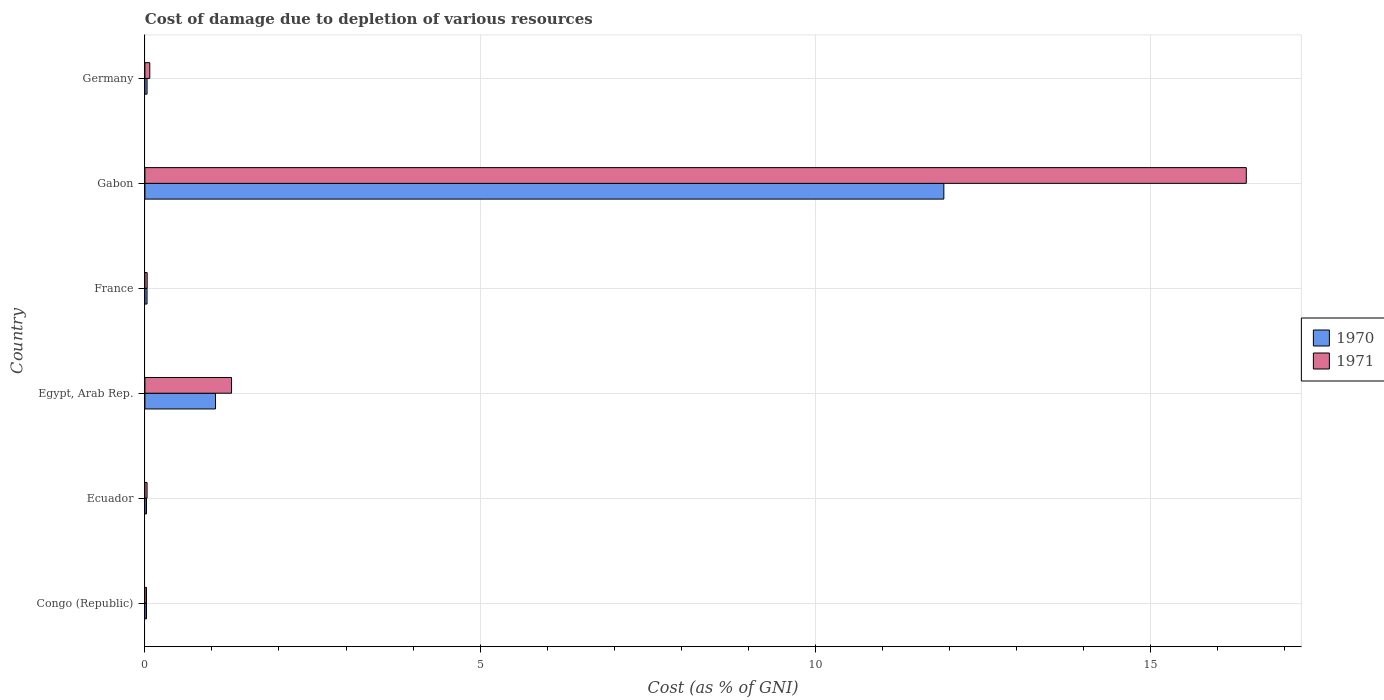How many different coloured bars are there?
Offer a terse response. 2. How many groups of bars are there?
Your response must be concise. 6. Are the number of bars per tick equal to the number of legend labels?
Your answer should be very brief. Yes. How many bars are there on the 6th tick from the top?
Offer a terse response. 2. How many bars are there on the 2nd tick from the bottom?
Your answer should be compact. 2. In how many cases, is the number of bars for a given country not equal to the number of legend labels?
Your response must be concise. 0. What is the cost of damage caused due to the depletion of various resources in 1970 in Congo (Republic)?
Offer a very short reply. 0.02. Across all countries, what is the maximum cost of damage caused due to the depletion of various resources in 1970?
Offer a very short reply. 11.92. Across all countries, what is the minimum cost of damage caused due to the depletion of various resources in 1970?
Provide a succinct answer. 0.02. In which country was the cost of damage caused due to the depletion of various resources in 1970 maximum?
Give a very brief answer. Gabon. In which country was the cost of damage caused due to the depletion of various resources in 1971 minimum?
Make the answer very short. Congo (Republic). What is the total cost of damage caused due to the depletion of various resources in 1970 in the graph?
Your answer should be compact. 13.08. What is the difference between the cost of damage caused due to the depletion of various resources in 1971 in Congo (Republic) and that in Ecuador?
Ensure brevity in your answer.  -0.01. What is the difference between the cost of damage caused due to the depletion of various resources in 1971 in Egypt, Arab Rep. and the cost of damage caused due to the depletion of various resources in 1970 in France?
Offer a very short reply. 1.26. What is the average cost of damage caused due to the depletion of various resources in 1970 per country?
Your response must be concise. 2.18. What is the difference between the cost of damage caused due to the depletion of various resources in 1970 and cost of damage caused due to the depletion of various resources in 1971 in Gabon?
Your answer should be very brief. -4.51. In how many countries, is the cost of damage caused due to the depletion of various resources in 1971 greater than 13 %?
Your answer should be very brief. 1. What is the ratio of the cost of damage caused due to the depletion of various resources in 1971 in Congo (Republic) to that in Germany?
Offer a terse response. 0.32. Is the cost of damage caused due to the depletion of various resources in 1971 in Ecuador less than that in Gabon?
Offer a very short reply. Yes. What is the difference between the highest and the second highest cost of damage caused due to the depletion of various resources in 1971?
Your response must be concise. 15.14. What is the difference between the highest and the lowest cost of damage caused due to the depletion of various resources in 1970?
Give a very brief answer. 11.9. What does the 1st bar from the bottom in France represents?
Provide a succinct answer. 1970. How many bars are there?
Provide a short and direct response. 12. Are the values on the major ticks of X-axis written in scientific E-notation?
Offer a terse response. No. How many legend labels are there?
Your response must be concise. 2. How are the legend labels stacked?
Provide a succinct answer. Vertical. What is the title of the graph?
Offer a terse response. Cost of damage due to depletion of various resources. Does "1963" appear as one of the legend labels in the graph?
Provide a succinct answer. No. What is the label or title of the X-axis?
Provide a succinct answer. Cost (as % of GNI). What is the label or title of the Y-axis?
Provide a short and direct response. Country. What is the Cost (as % of GNI) of 1970 in Congo (Republic)?
Your answer should be very brief. 0.02. What is the Cost (as % of GNI) of 1971 in Congo (Republic)?
Provide a succinct answer. 0.02. What is the Cost (as % of GNI) in 1970 in Ecuador?
Offer a terse response. 0.02. What is the Cost (as % of GNI) of 1971 in Ecuador?
Your answer should be compact. 0.03. What is the Cost (as % of GNI) of 1970 in Egypt, Arab Rep.?
Your answer should be very brief. 1.05. What is the Cost (as % of GNI) of 1971 in Egypt, Arab Rep.?
Offer a very short reply. 1.29. What is the Cost (as % of GNI) of 1970 in France?
Ensure brevity in your answer.  0.03. What is the Cost (as % of GNI) of 1971 in France?
Your answer should be very brief. 0.03. What is the Cost (as % of GNI) in 1970 in Gabon?
Your answer should be compact. 11.92. What is the Cost (as % of GNI) in 1971 in Gabon?
Make the answer very short. 16.43. What is the Cost (as % of GNI) in 1970 in Germany?
Ensure brevity in your answer.  0.03. What is the Cost (as % of GNI) of 1971 in Germany?
Make the answer very short. 0.07. Across all countries, what is the maximum Cost (as % of GNI) of 1970?
Ensure brevity in your answer.  11.92. Across all countries, what is the maximum Cost (as % of GNI) in 1971?
Your answer should be compact. 16.43. Across all countries, what is the minimum Cost (as % of GNI) of 1970?
Offer a very short reply. 0.02. Across all countries, what is the minimum Cost (as % of GNI) in 1971?
Give a very brief answer. 0.02. What is the total Cost (as % of GNI) in 1970 in the graph?
Keep it short and to the point. 13.08. What is the total Cost (as % of GNI) in 1971 in the graph?
Ensure brevity in your answer.  17.89. What is the difference between the Cost (as % of GNI) in 1971 in Congo (Republic) and that in Ecuador?
Your response must be concise. -0.01. What is the difference between the Cost (as % of GNI) of 1970 in Congo (Republic) and that in Egypt, Arab Rep.?
Provide a short and direct response. -1.03. What is the difference between the Cost (as % of GNI) in 1971 in Congo (Republic) and that in Egypt, Arab Rep.?
Your answer should be very brief. -1.27. What is the difference between the Cost (as % of GNI) in 1970 in Congo (Republic) and that in France?
Offer a very short reply. -0.01. What is the difference between the Cost (as % of GNI) in 1971 in Congo (Republic) and that in France?
Your answer should be compact. -0.01. What is the difference between the Cost (as % of GNI) of 1970 in Congo (Republic) and that in Gabon?
Provide a succinct answer. -11.9. What is the difference between the Cost (as % of GNI) in 1971 in Congo (Republic) and that in Gabon?
Your response must be concise. -16.41. What is the difference between the Cost (as % of GNI) in 1970 in Congo (Republic) and that in Germany?
Your answer should be compact. -0.01. What is the difference between the Cost (as % of GNI) in 1971 in Congo (Republic) and that in Germany?
Make the answer very short. -0.05. What is the difference between the Cost (as % of GNI) in 1970 in Ecuador and that in Egypt, Arab Rep.?
Your response must be concise. -1.03. What is the difference between the Cost (as % of GNI) in 1971 in Ecuador and that in Egypt, Arab Rep.?
Keep it short and to the point. -1.26. What is the difference between the Cost (as % of GNI) in 1970 in Ecuador and that in France?
Give a very brief answer. -0.01. What is the difference between the Cost (as % of GNI) in 1971 in Ecuador and that in France?
Your answer should be very brief. -0. What is the difference between the Cost (as % of GNI) in 1970 in Ecuador and that in Gabon?
Give a very brief answer. -11.9. What is the difference between the Cost (as % of GNI) in 1971 in Ecuador and that in Gabon?
Keep it short and to the point. -16.4. What is the difference between the Cost (as % of GNI) of 1970 in Ecuador and that in Germany?
Your answer should be compact. -0.01. What is the difference between the Cost (as % of GNI) in 1971 in Ecuador and that in Germany?
Ensure brevity in your answer.  -0.04. What is the difference between the Cost (as % of GNI) in 1970 in Egypt, Arab Rep. and that in France?
Offer a very short reply. 1.02. What is the difference between the Cost (as % of GNI) in 1971 in Egypt, Arab Rep. and that in France?
Your answer should be very brief. 1.26. What is the difference between the Cost (as % of GNI) in 1970 in Egypt, Arab Rep. and that in Gabon?
Offer a terse response. -10.87. What is the difference between the Cost (as % of GNI) of 1971 in Egypt, Arab Rep. and that in Gabon?
Make the answer very short. -15.14. What is the difference between the Cost (as % of GNI) of 1970 in Egypt, Arab Rep. and that in Germany?
Keep it short and to the point. 1.02. What is the difference between the Cost (as % of GNI) in 1971 in Egypt, Arab Rep. and that in Germany?
Offer a very short reply. 1.22. What is the difference between the Cost (as % of GNI) of 1970 in France and that in Gabon?
Give a very brief answer. -11.89. What is the difference between the Cost (as % of GNI) in 1971 in France and that in Gabon?
Make the answer very short. -16.4. What is the difference between the Cost (as % of GNI) of 1970 in France and that in Germany?
Offer a very short reply. -0. What is the difference between the Cost (as % of GNI) of 1971 in France and that in Germany?
Offer a very short reply. -0.04. What is the difference between the Cost (as % of GNI) in 1970 in Gabon and that in Germany?
Give a very brief answer. 11.89. What is the difference between the Cost (as % of GNI) in 1971 in Gabon and that in Germany?
Your response must be concise. 16.36. What is the difference between the Cost (as % of GNI) in 1970 in Congo (Republic) and the Cost (as % of GNI) in 1971 in Ecuador?
Your response must be concise. -0.01. What is the difference between the Cost (as % of GNI) of 1970 in Congo (Republic) and the Cost (as % of GNI) of 1971 in Egypt, Arab Rep.?
Offer a very short reply. -1.27. What is the difference between the Cost (as % of GNI) in 1970 in Congo (Republic) and the Cost (as % of GNI) in 1971 in France?
Offer a terse response. -0.01. What is the difference between the Cost (as % of GNI) of 1970 in Congo (Republic) and the Cost (as % of GNI) of 1971 in Gabon?
Keep it short and to the point. -16.41. What is the difference between the Cost (as % of GNI) of 1970 in Congo (Republic) and the Cost (as % of GNI) of 1971 in Germany?
Your answer should be very brief. -0.05. What is the difference between the Cost (as % of GNI) in 1970 in Ecuador and the Cost (as % of GNI) in 1971 in Egypt, Arab Rep.?
Keep it short and to the point. -1.27. What is the difference between the Cost (as % of GNI) of 1970 in Ecuador and the Cost (as % of GNI) of 1971 in France?
Ensure brevity in your answer.  -0.01. What is the difference between the Cost (as % of GNI) of 1970 in Ecuador and the Cost (as % of GNI) of 1971 in Gabon?
Offer a terse response. -16.41. What is the difference between the Cost (as % of GNI) in 1970 in Ecuador and the Cost (as % of GNI) in 1971 in Germany?
Give a very brief answer. -0.05. What is the difference between the Cost (as % of GNI) of 1970 in Egypt, Arab Rep. and the Cost (as % of GNI) of 1971 in Gabon?
Your response must be concise. -15.38. What is the difference between the Cost (as % of GNI) of 1970 in Egypt, Arab Rep. and the Cost (as % of GNI) of 1971 in Germany?
Provide a succinct answer. 0.98. What is the difference between the Cost (as % of GNI) in 1970 in France and the Cost (as % of GNI) in 1971 in Gabon?
Keep it short and to the point. -16.4. What is the difference between the Cost (as % of GNI) in 1970 in France and the Cost (as % of GNI) in 1971 in Germany?
Your response must be concise. -0.04. What is the difference between the Cost (as % of GNI) of 1970 in Gabon and the Cost (as % of GNI) of 1971 in Germany?
Your answer should be compact. 11.85. What is the average Cost (as % of GNI) in 1970 per country?
Give a very brief answer. 2.18. What is the average Cost (as % of GNI) of 1971 per country?
Give a very brief answer. 2.98. What is the difference between the Cost (as % of GNI) in 1970 and Cost (as % of GNI) in 1971 in Congo (Republic)?
Ensure brevity in your answer.  0. What is the difference between the Cost (as % of GNI) of 1970 and Cost (as % of GNI) of 1971 in Ecuador?
Make the answer very short. -0.01. What is the difference between the Cost (as % of GNI) in 1970 and Cost (as % of GNI) in 1971 in Egypt, Arab Rep.?
Give a very brief answer. -0.24. What is the difference between the Cost (as % of GNI) in 1970 and Cost (as % of GNI) in 1971 in France?
Provide a short and direct response. -0. What is the difference between the Cost (as % of GNI) in 1970 and Cost (as % of GNI) in 1971 in Gabon?
Provide a succinct answer. -4.51. What is the difference between the Cost (as % of GNI) of 1970 and Cost (as % of GNI) of 1971 in Germany?
Give a very brief answer. -0.04. What is the ratio of the Cost (as % of GNI) in 1970 in Congo (Republic) to that in Ecuador?
Offer a very short reply. 1.01. What is the ratio of the Cost (as % of GNI) of 1971 in Congo (Republic) to that in Ecuador?
Offer a very short reply. 0.73. What is the ratio of the Cost (as % of GNI) in 1970 in Congo (Republic) to that in Egypt, Arab Rep.?
Ensure brevity in your answer.  0.02. What is the ratio of the Cost (as % of GNI) of 1971 in Congo (Republic) to that in Egypt, Arab Rep.?
Give a very brief answer. 0.02. What is the ratio of the Cost (as % of GNI) in 1970 in Congo (Republic) to that in France?
Your answer should be very brief. 0.75. What is the ratio of the Cost (as % of GNI) of 1971 in Congo (Republic) to that in France?
Provide a short and direct response. 0.7. What is the ratio of the Cost (as % of GNI) in 1970 in Congo (Republic) to that in Gabon?
Your answer should be compact. 0. What is the ratio of the Cost (as % of GNI) of 1971 in Congo (Republic) to that in Gabon?
Keep it short and to the point. 0. What is the ratio of the Cost (as % of GNI) in 1970 in Congo (Republic) to that in Germany?
Offer a very short reply. 0.74. What is the ratio of the Cost (as % of GNI) in 1971 in Congo (Republic) to that in Germany?
Offer a terse response. 0.32. What is the ratio of the Cost (as % of GNI) of 1970 in Ecuador to that in Egypt, Arab Rep.?
Offer a very short reply. 0.02. What is the ratio of the Cost (as % of GNI) of 1971 in Ecuador to that in Egypt, Arab Rep.?
Offer a very short reply. 0.02. What is the ratio of the Cost (as % of GNI) of 1970 in Ecuador to that in France?
Make the answer very short. 0.74. What is the ratio of the Cost (as % of GNI) in 1971 in Ecuador to that in France?
Keep it short and to the point. 0.96. What is the ratio of the Cost (as % of GNI) of 1970 in Ecuador to that in Gabon?
Your response must be concise. 0. What is the ratio of the Cost (as % of GNI) of 1971 in Ecuador to that in Gabon?
Your answer should be compact. 0. What is the ratio of the Cost (as % of GNI) in 1970 in Ecuador to that in Germany?
Provide a short and direct response. 0.73. What is the ratio of the Cost (as % of GNI) of 1971 in Ecuador to that in Germany?
Your answer should be compact. 0.44. What is the ratio of the Cost (as % of GNI) in 1970 in Egypt, Arab Rep. to that in France?
Your answer should be very brief. 33.37. What is the ratio of the Cost (as % of GNI) of 1971 in Egypt, Arab Rep. to that in France?
Provide a succinct answer. 38.77. What is the ratio of the Cost (as % of GNI) in 1970 in Egypt, Arab Rep. to that in Gabon?
Keep it short and to the point. 0.09. What is the ratio of the Cost (as % of GNI) in 1971 in Egypt, Arab Rep. to that in Gabon?
Ensure brevity in your answer.  0.08. What is the ratio of the Cost (as % of GNI) of 1970 in Egypt, Arab Rep. to that in Germany?
Offer a very short reply. 32.93. What is the ratio of the Cost (as % of GNI) of 1971 in Egypt, Arab Rep. to that in Germany?
Your answer should be compact. 17.84. What is the ratio of the Cost (as % of GNI) of 1970 in France to that in Gabon?
Make the answer very short. 0. What is the ratio of the Cost (as % of GNI) in 1971 in France to that in Gabon?
Keep it short and to the point. 0. What is the ratio of the Cost (as % of GNI) in 1970 in France to that in Germany?
Provide a short and direct response. 0.99. What is the ratio of the Cost (as % of GNI) of 1971 in France to that in Germany?
Offer a very short reply. 0.46. What is the ratio of the Cost (as % of GNI) in 1970 in Gabon to that in Germany?
Give a very brief answer. 372.66. What is the ratio of the Cost (as % of GNI) of 1971 in Gabon to that in Germany?
Your response must be concise. 226.83. What is the difference between the highest and the second highest Cost (as % of GNI) of 1970?
Your answer should be very brief. 10.87. What is the difference between the highest and the second highest Cost (as % of GNI) of 1971?
Your answer should be very brief. 15.14. What is the difference between the highest and the lowest Cost (as % of GNI) in 1970?
Provide a short and direct response. 11.9. What is the difference between the highest and the lowest Cost (as % of GNI) of 1971?
Make the answer very short. 16.41. 